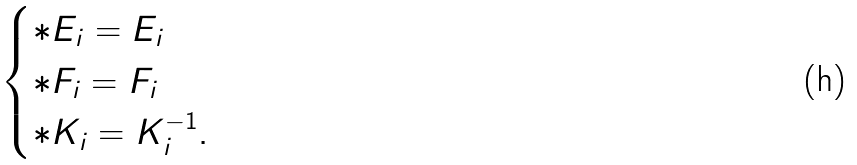Convert formula to latex. <formula><loc_0><loc_0><loc_500><loc_500>\begin{cases} * E _ { i } = E _ { i } \\ * F _ { i } = F _ { i } \\ * K _ { i } = K _ { i } ^ { - 1 } . \end{cases}</formula> 